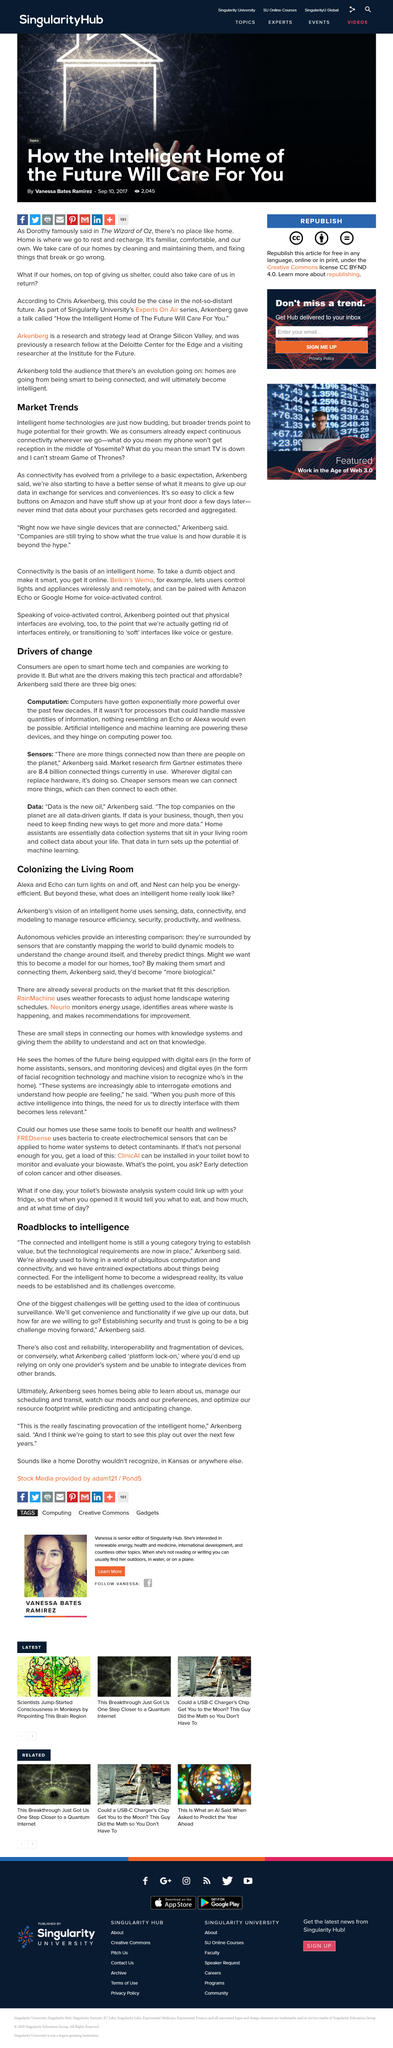Outline some significant characteristics in this image. Connectivity has evolved from a privilege to a basic expectation for consumers, as evidenced by market trends that show consumers now prioritize connectivity above all else. The writer asserts that Alexa and Echo can perform the service of turning lights on and off. In recent decades, computers have become exponentially more powerful, demonstrating a remarkable increase in their capability and performance. According to Arkenberg, there are three major drivers that are making technology practical and more affordable. We are already accustomed to living in a world of ubiquitous computation and connectivity. 